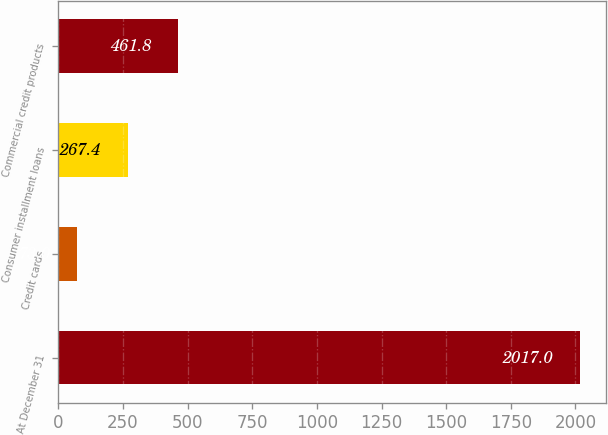Convert chart to OTSL. <chart><loc_0><loc_0><loc_500><loc_500><bar_chart><fcel>At December 31<fcel>Credit cards<fcel>Consumer installment loans<fcel>Commercial credit products<nl><fcel>2017<fcel>73<fcel>267.4<fcel>461.8<nl></chart> 